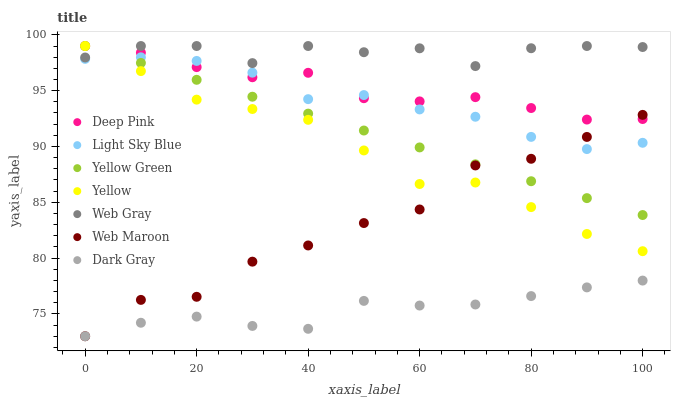Does Dark Gray have the minimum area under the curve?
Answer yes or no. Yes. Does Web Gray have the maximum area under the curve?
Answer yes or no. Yes. Does Yellow Green have the minimum area under the curve?
Answer yes or no. No. Does Yellow Green have the maximum area under the curve?
Answer yes or no. No. Is Yellow Green the smoothest?
Answer yes or no. Yes. Is Web Maroon the roughest?
Answer yes or no. Yes. Is Web Maroon the smoothest?
Answer yes or no. No. Is Yellow Green the roughest?
Answer yes or no. No. Does Web Maroon have the lowest value?
Answer yes or no. Yes. Does Yellow Green have the lowest value?
Answer yes or no. No. Does Deep Pink have the highest value?
Answer yes or no. Yes. Does Web Maroon have the highest value?
Answer yes or no. No. Is Web Maroon less than Web Gray?
Answer yes or no. Yes. Is Web Gray greater than Dark Gray?
Answer yes or no. Yes. Does Web Maroon intersect Light Sky Blue?
Answer yes or no. Yes. Is Web Maroon less than Light Sky Blue?
Answer yes or no. No. Is Web Maroon greater than Light Sky Blue?
Answer yes or no. No. Does Web Maroon intersect Web Gray?
Answer yes or no. No. 